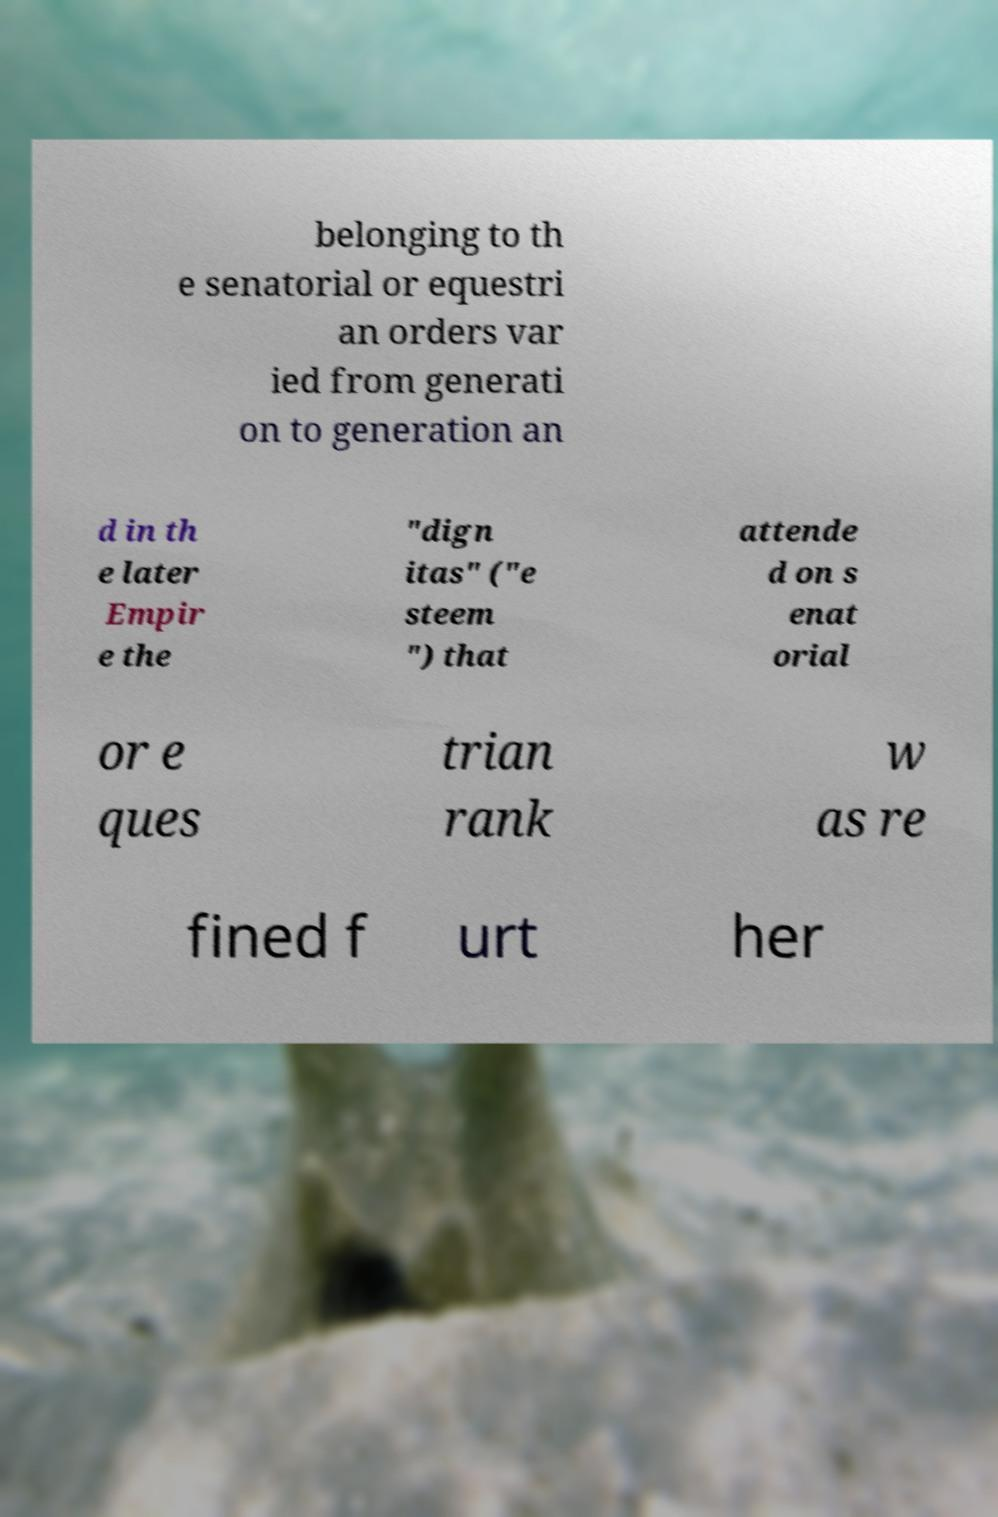Can you read and provide the text displayed in the image?This photo seems to have some interesting text. Can you extract and type it out for me? belonging to th e senatorial or equestri an orders var ied from generati on to generation an d in th e later Empir e the "dign itas" ("e steem ") that attende d on s enat orial or e ques trian rank w as re fined f urt her 